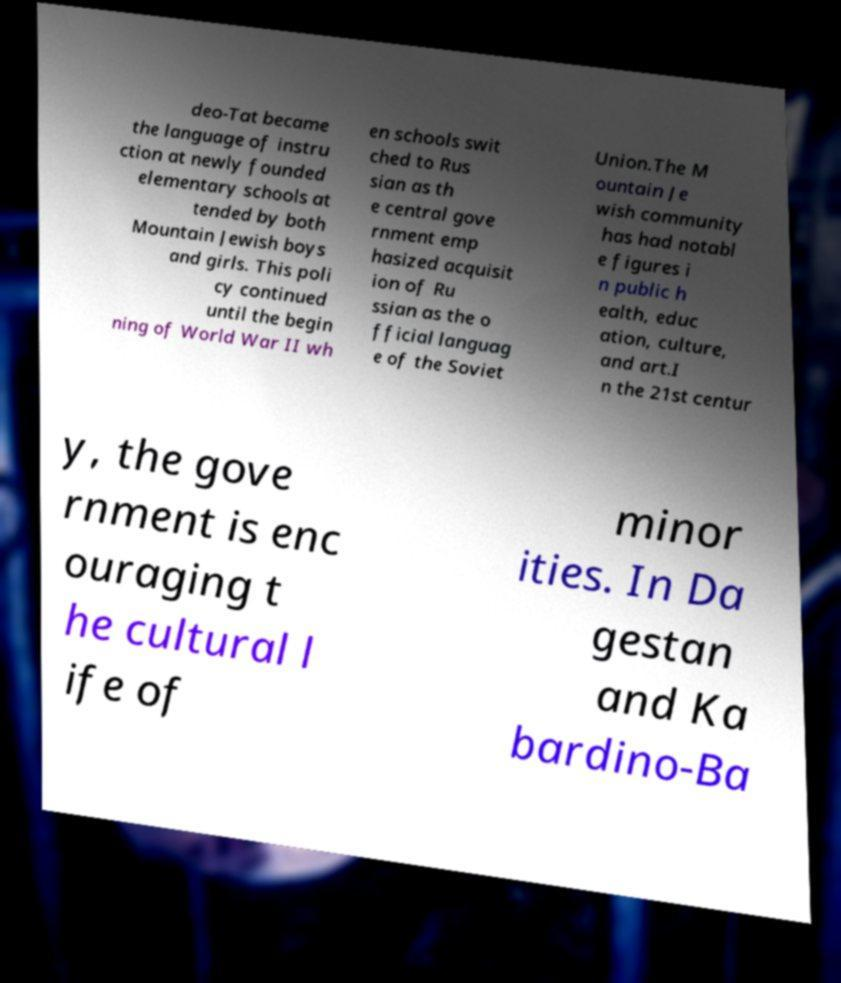Please read and relay the text visible in this image. What does it say? deo-Tat became the language of instru ction at newly founded elementary schools at tended by both Mountain Jewish boys and girls. This poli cy continued until the begin ning of World War II wh en schools swit ched to Rus sian as th e central gove rnment emp hasized acquisit ion of Ru ssian as the o fficial languag e of the Soviet Union.The M ountain Je wish community has had notabl e figures i n public h ealth, educ ation, culture, and art.I n the 21st centur y, the gove rnment is enc ouraging t he cultural l ife of minor ities. In Da gestan and Ka bardino-Ba 